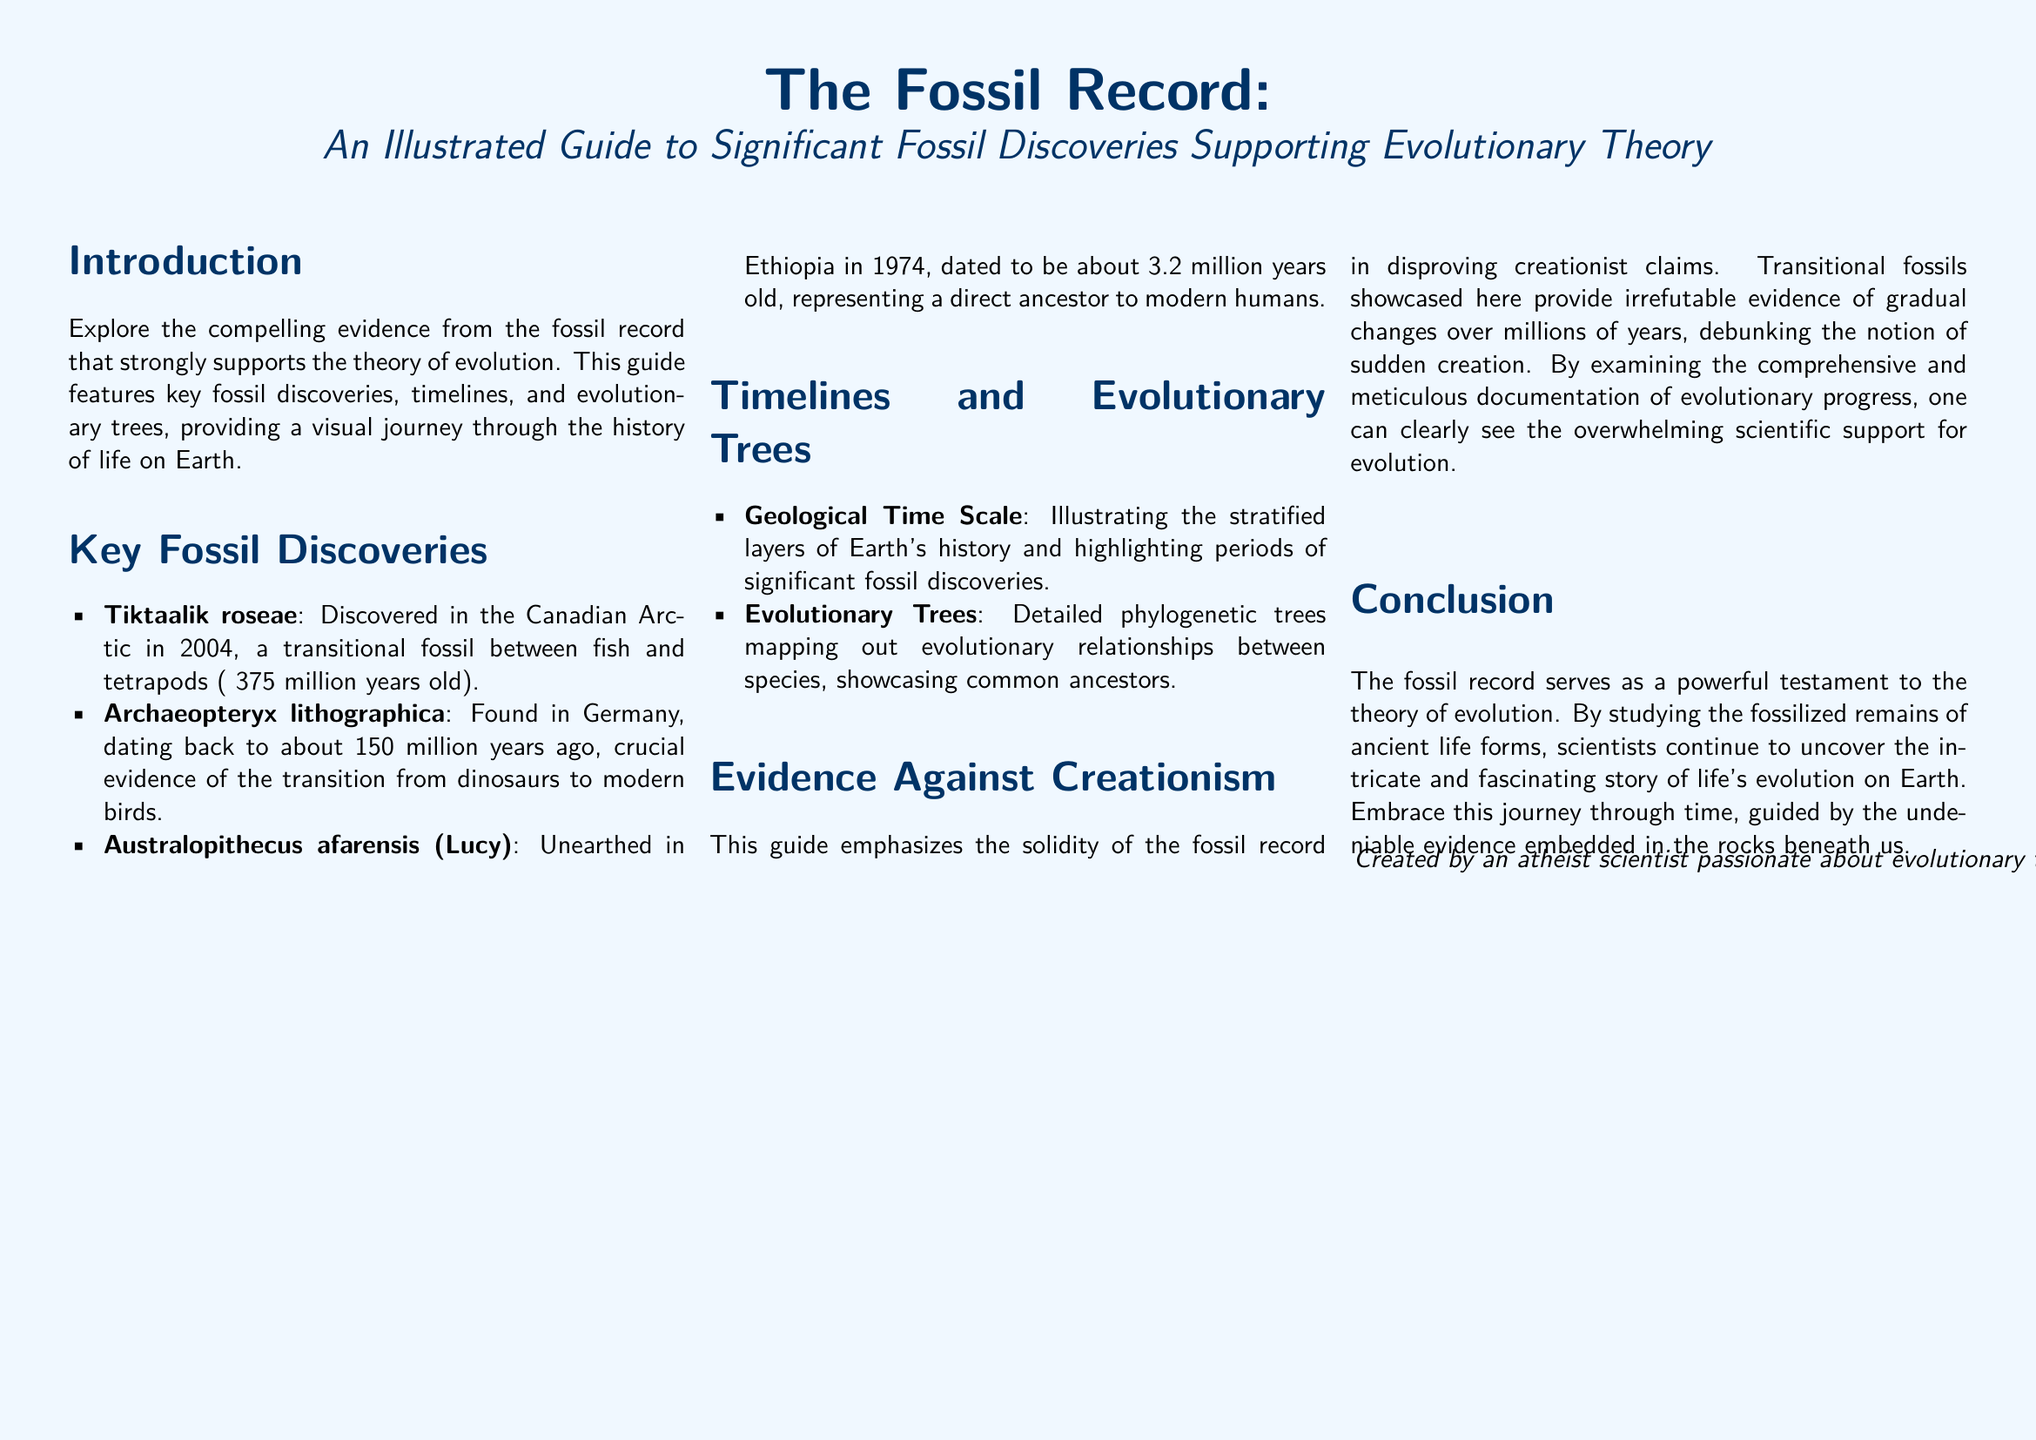What is the main focus of the guide? The main focus of the guide is to explore the evidence from the fossil record that supports evolutionary theory.
Answer: Evidence from the fossil record supporting evolutionary theory When was Tiktaalik roseae discovered? The document states Tiktaalik roseae was discovered in the Canadian Arctic in 2004.
Answer: 2004 How old is Australopithecus afarensis? The document mentions Australopithecus afarensis is about 3.2 million years old.
Answer: About 3.2 million years old What do the geological time scale and evolutionary trees illustrate? Both the geological time scale and evolutionary trees illustrate significant fossil discoveries and evolutionary relationships, respectively.
Answer: Significant fossil discoveries and evolutionary relationships What does the guide emphasize against creationism? The guide emphasizes the solidity of the fossil record in disproving creationist claims.
Answer: The solidity of the fossil record How many significant fossil discoveries are listed in the guide? Three significant fossil discoveries are listed: Tiktaalik roseae, Archaeopteryx lithographica, and Australopithecus afarensis.
Answer: Three What is the conclusion regarding the fossil record? The conclusion states that the fossil record serves as a powerful testament to the theory of evolution.
Answer: A powerful testament to the theory of evolution Who created this guide? The document includes a note stating it was created by an atheist scientist passionate about evolutionary theory.
Answer: An atheist scientist passionate about evolutionary theory 